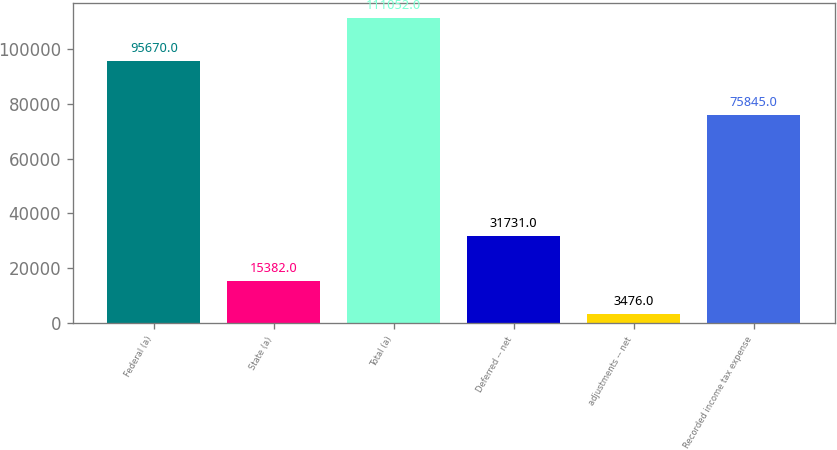Convert chart to OTSL. <chart><loc_0><loc_0><loc_500><loc_500><bar_chart><fcel>Federal (a)<fcel>State (a)<fcel>Total (a)<fcel>Deferred -- net<fcel>adjustments -- net<fcel>Recorded income tax expense<nl><fcel>95670<fcel>15382<fcel>111052<fcel>31731<fcel>3476<fcel>75845<nl></chart> 